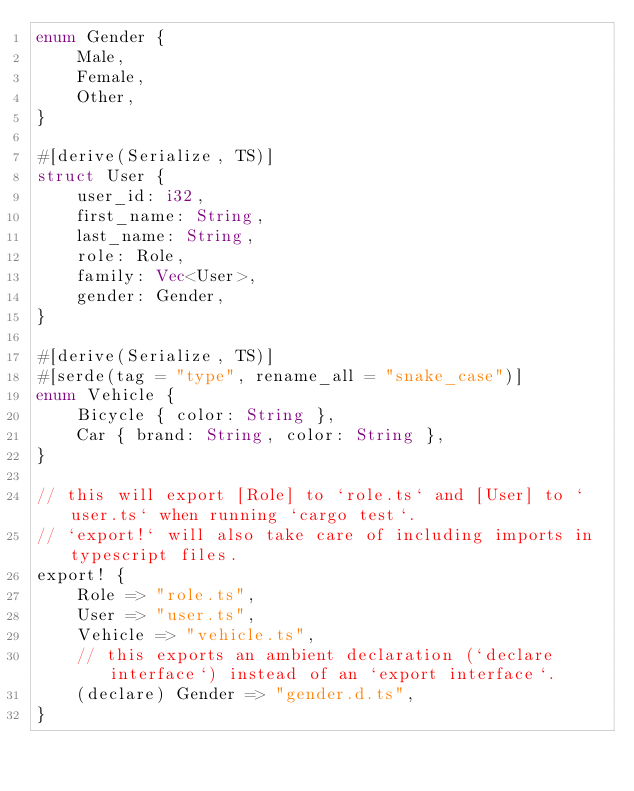<code> <loc_0><loc_0><loc_500><loc_500><_Rust_>enum Gender {
    Male,
    Female,
    Other,
}

#[derive(Serialize, TS)]
struct User {
    user_id: i32,
    first_name: String,
    last_name: String,
    role: Role,
    family: Vec<User>,
    gender: Gender,
}

#[derive(Serialize, TS)]
#[serde(tag = "type", rename_all = "snake_case")]
enum Vehicle {
    Bicycle { color: String },
    Car { brand: String, color: String },
}

// this will export [Role] to `role.ts` and [User] to `user.ts` when running `cargo test`.
// `export!` will also take care of including imports in typescript files.
export! {
    Role => "role.ts",
    User => "user.ts",
    Vehicle => "vehicle.ts",
    // this exports an ambient declaration (`declare interface`) instead of an `export interface`.
    (declare) Gender => "gender.d.ts",
}
</code> 